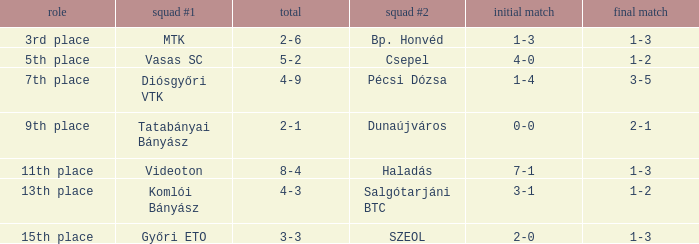Could you parse the entire table as a dict? {'header': ['role', 'squad #1', 'total', 'squad #2', 'initial match', 'final match'], 'rows': [['3rd place', 'MTK', '2-6', 'Bp. Honvéd', '1-3', '1-3'], ['5th place', 'Vasas SC', '5-2', 'Csepel', '4-0', '1-2'], ['7th place', 'Diósgyőri VTK', '4-9', 'Pécsi Dózsa', '1-4', '3-5'], ['9th place', 'Tatabányai Bányász', '2-1', 'Dunaújváros', '0-0', '2-1'], ['11th place', 'Videoton', '8-4', 'Haladás', '7-1', '1-3'], ['13th place', 'Komlói Bányász', '4-3', 'Salgótarjáni BTC', '3-1', '1-2'], ['15th place', 'Győri ETO', '3-3', 'SZEOL', '2-0', '1-3']]} What is the 2nd leg of the 4-9 agg.? 3-5. 